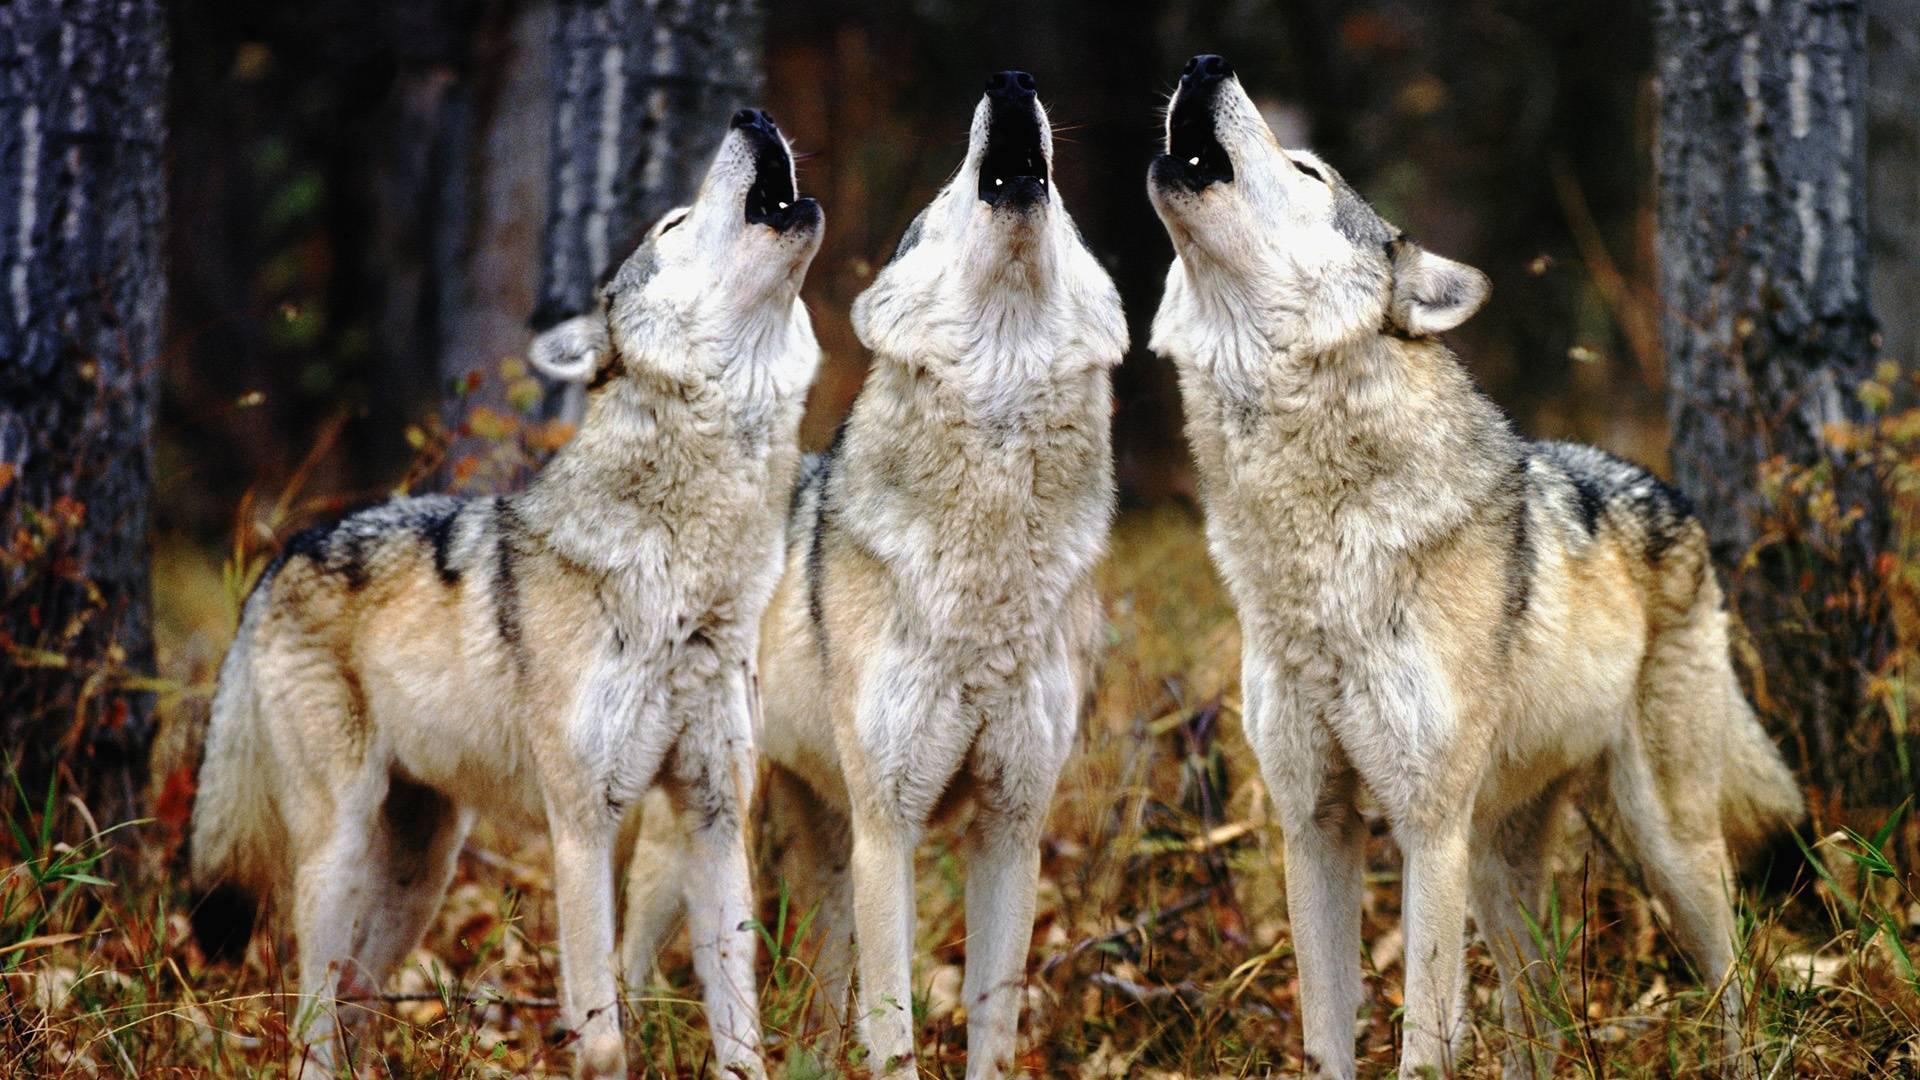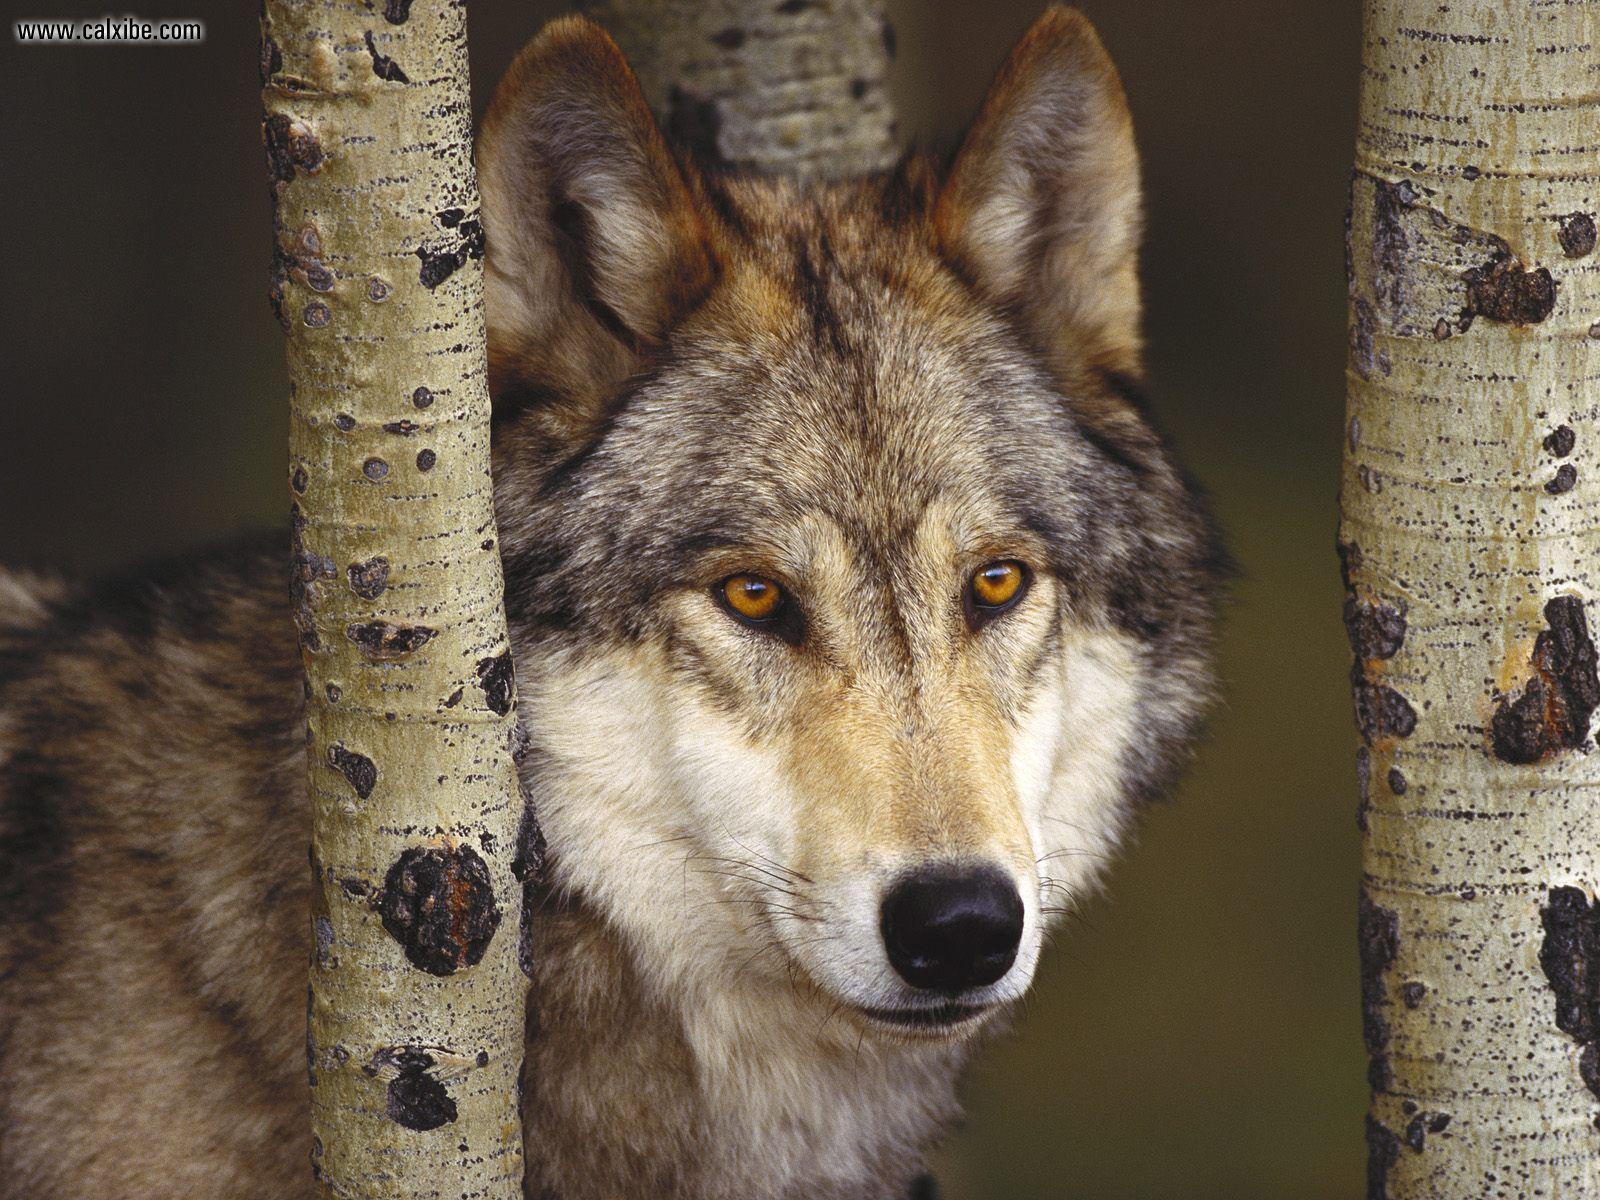The first image is the image on the left, the second image is the image on the right. Evaluate the accuracy of this statement regarding the images: "The left image contains exactly three wolves.". Is it true? Answer yes or no. Yes. The first image is the image on the left, the second image is the image on the right. Given the left and right images, does the statement "An image shows a horizontal row of exactly three wolves, and all are in similar poses." hold true? Answer yes or no. Yes. 